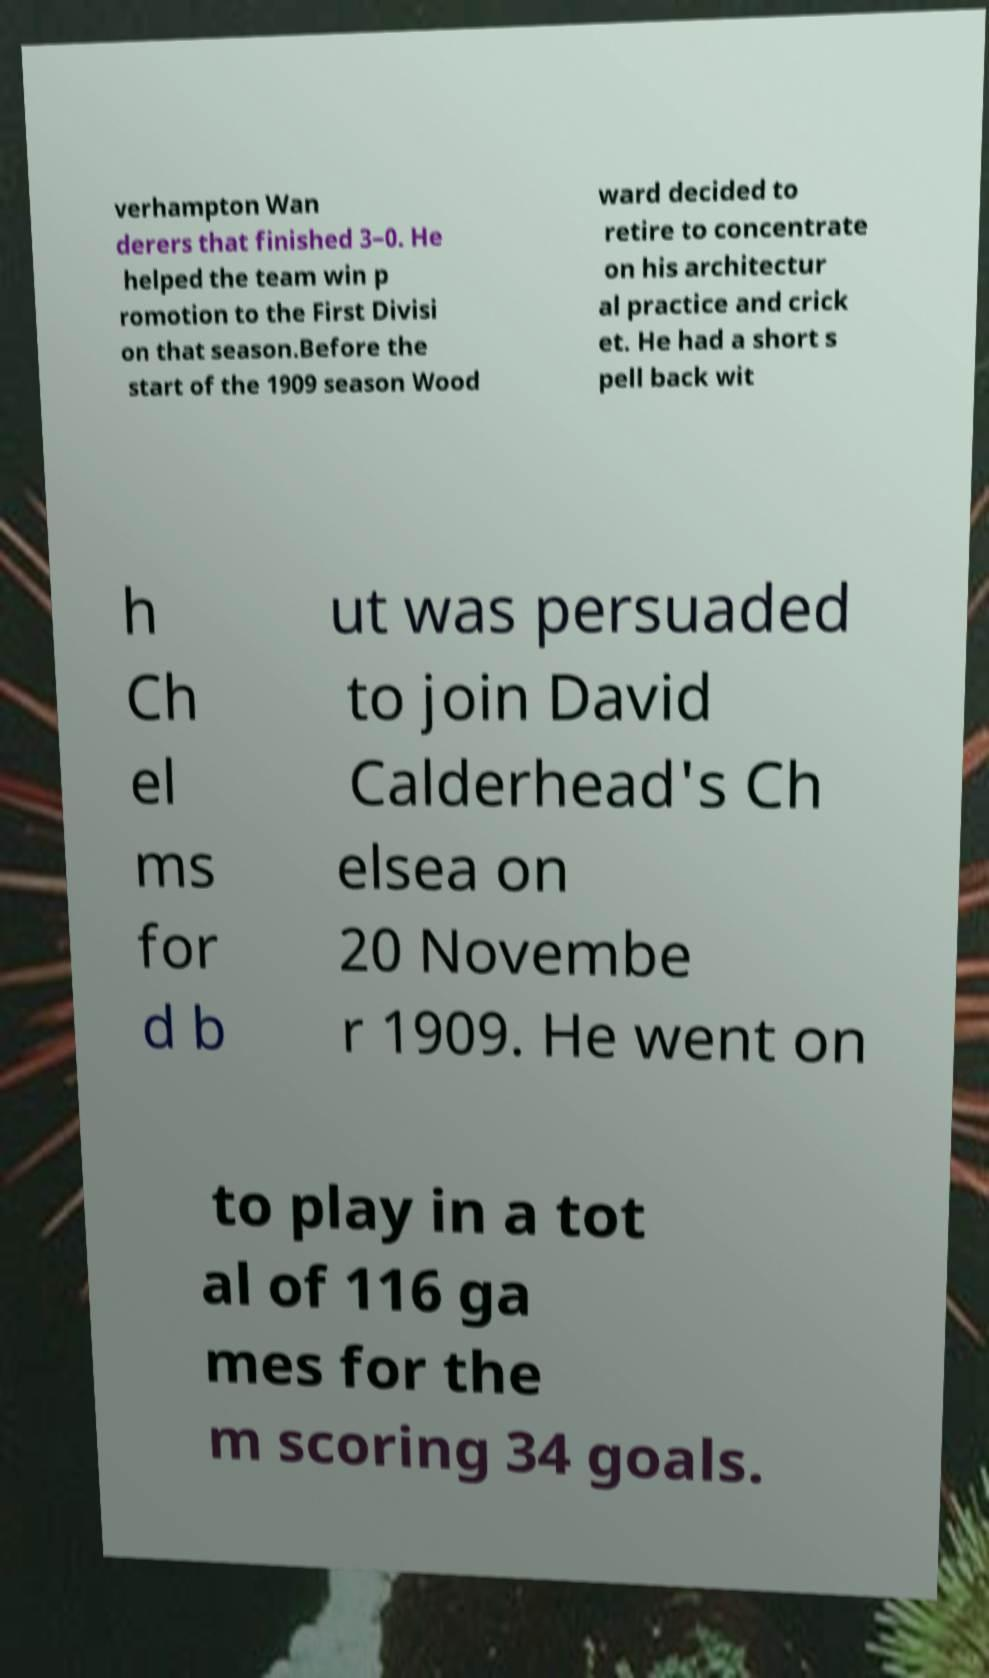Please read and relay the text visible in this image. What does it say? verhampton Wan derers that finished 3–0. He helped the team win p romotion to the First Divisi on that season.Before the start of the 1909 season Wood ward decided to retire to concentrate on his architectur al practice and crick et. He had a short s pell back wit h Ch el ms for d b ut was persuaded to join David Calderhead's Ch elsea on 20 Novembe r 1909. He went on to play in a tot al of 116 ga mes for the m scoring 34 goals. 